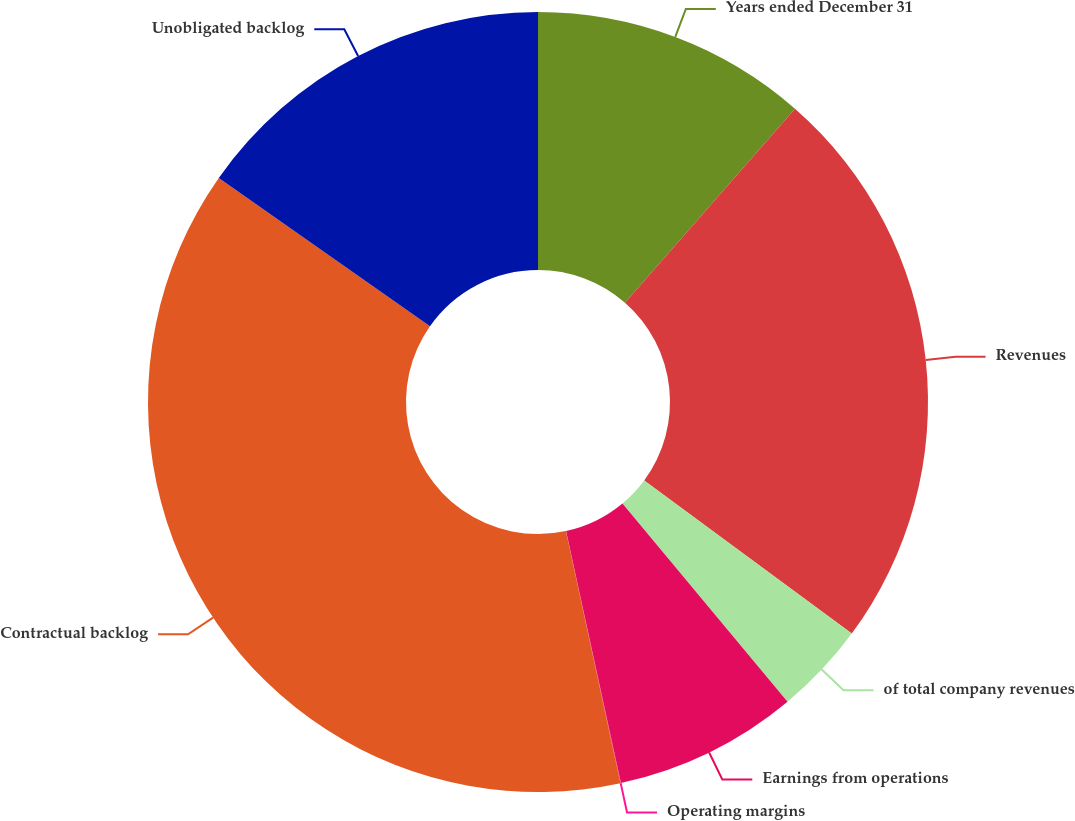<chart> <loc_0><loc_0><loc_500><loc_500><pie_chart><fcel>Years ended December 31<fcel>Revenues<fcel>of total company revenues<fcel>Earnings from operations<fcel>Operating margins<fcel>Contractual backlog<fcel>Unobligated backlog<nl><fcel>11.45%<fcel>23.67%<fcel>3.83%<fcel>7.64%<fcel>0.02%<fcel>38.13%<fcel>15.26%<nl></chart> 